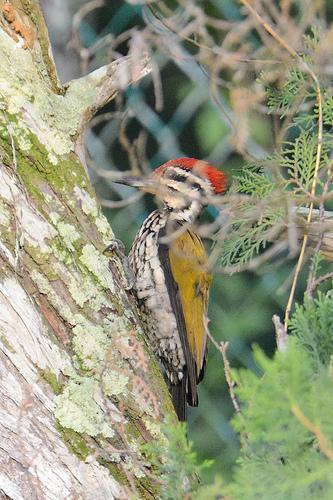How many birds are in the picture?
Give a very brief answer. 1. 